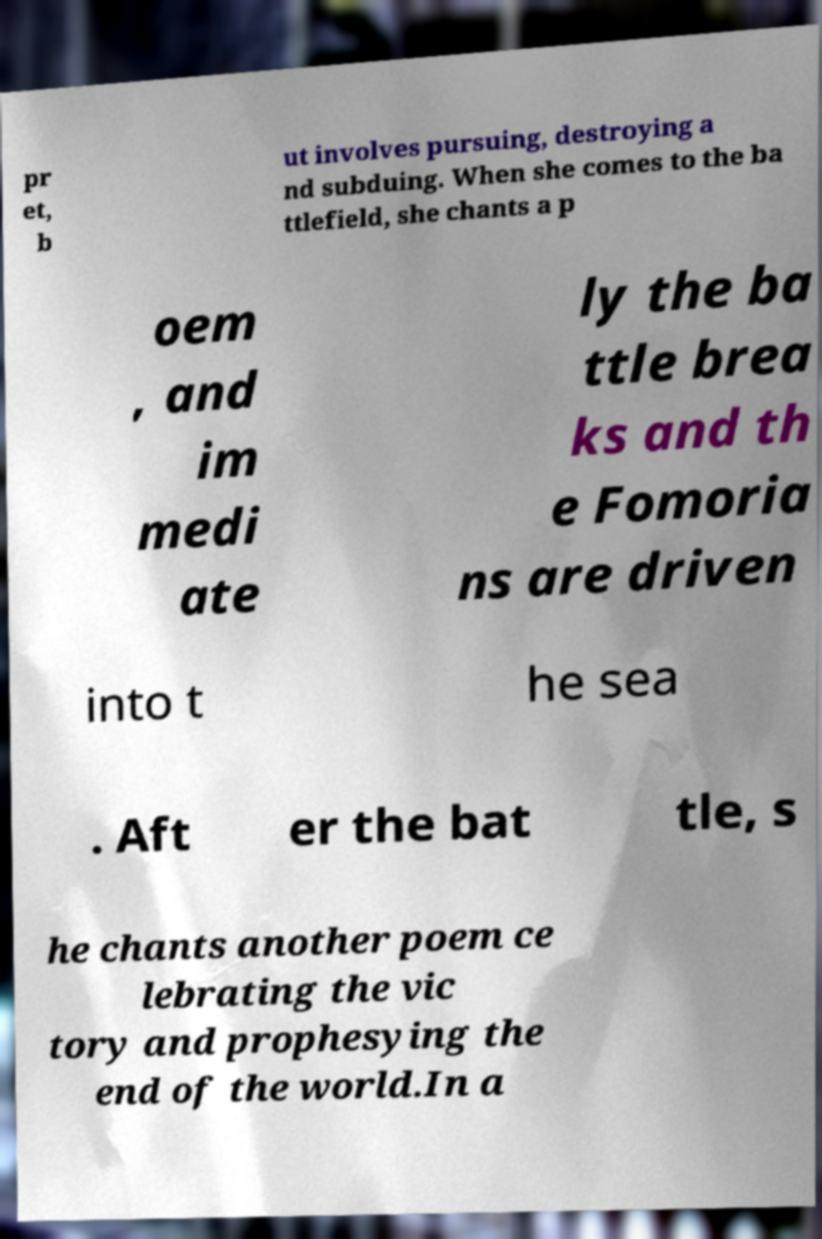Could you extract and type out the text from this image? pr et, b ut involves pursuing, destroying a nd subduing. When she comes to the ba ttlefield, she chants a p oem , and im medi ate ly the ba ttle brea ks and th e Fomoria ns are driven into t he sea . Aft er the bat tle, s he chants another poem ce lebrating the vic tory and prophesying the end of the world.In a 